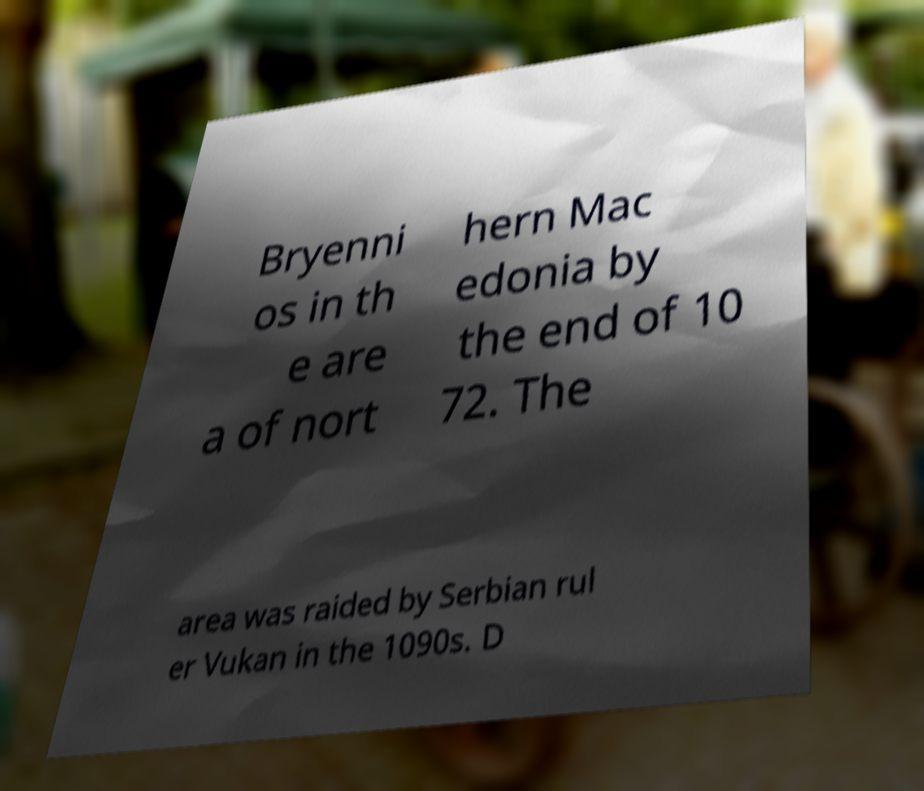Could you assist in decoding the text presented in this image and type it out clearly? Bryenni os in th e are a of nort hern Mac edonia by the end of 10 72. The area was raided by Serbian rul er Vukan in the 1090s. D 